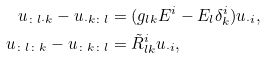Convert formula to latex. <formula><loc_0><loc_0><loc_500><loc_500>u _ { \colon l \cdot k } - u _ { \cdot k \colon l } & = ( g _ { l k } E ^ { i } - E _ { l } \delta ^ { i } _ { k } ) u _ { \cdot i } , \\ u _ { \colon l \colon k } - u _ { \colon k \colon l } & = \tilde { R } ^ { i } _ { l k } u _ { \cdot i } ,</formula> 